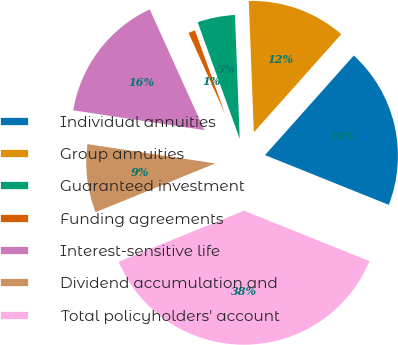<chart> <loc_0><loc_0><loc_500><loc_500><pie_chart><fcel>Individual annuities<fcel>Group annuities<fcel>Guaranteed investment<fcel>Funding agreements<fcel>Interest-sensitive life<fcel>Dividend accumulation and<fcel>Total policyholders' account<nl><fcel>19.5%<fcel>12.2%<fcel>4.9%<fcel>1.25%<fcel>15.85%<fcel>8.55%<fcel>37.76%<nl></chart> 